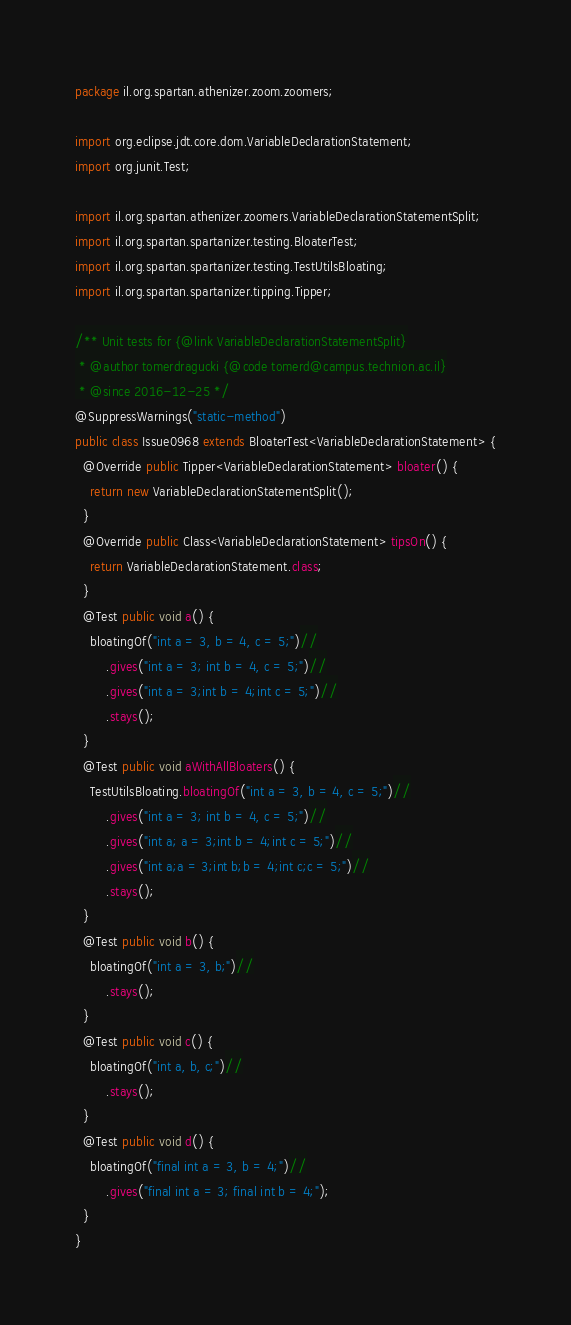Convert code to text. <code><loc_0><loc_0><loc_500><loc_500><_Java_>package il.org.spartan.athenizer.zoom.zoomers;

import org.eclipse.jdt.core.dom.VariableDeclarationStatement;
import org.junit.Test;

import il.org.spartan.athenizer.zoomers.VariableDeclarationStatementSplit;
import il.org.spartan.spartanizer.testing.BloaterTest;
import il.org.spartan.spartanizer.testing.TestUtilsBloating;
import il.org.spartan.spartanizer.tipping.Tipper;

/** Unit tests for {@link VariableDeclarationStatementSplit}
 * @author tomerdragucki {@code tomerd@campus.technion.ac.il}
 * @since 2016-12-25 */
@SuppressWarnings("static-method")
public class Issue0968 extends BloaterTest<VariableDeclarationStatement> {
  @Override public Tipper<VariableDeclarationStatement> bloater() {
    return new VariableDeclarationStatementSplit();
  }
  @Override public Class<VariableDeclarationStatement> tipsOn() {
    return VariableDeclarationStatement.class;
  }
  @Test public void a() {
    bloatingOf("int a = 3, b = 4, c = 5;")//
        .gives("int a = 3; int b = 4, c = 5;")//
        .gives("int a = 3;int b = 4;int c = 5;")//
        .stays();
  }
  @Test public void aWithAllBloaters() {
    TestUtilsBloating.bloatingOf("int a = 3, b = 4, c = 5;")//
        .gives("int a = 3; int b = 4, c = 5;")//
        .gives("int a; a = 3;int b = 4;int c = 5;")//
        .gives("int a;a = 3;int b;b = 4;int c;c = 5;")//
        .stays();
  }
  @Test public void b() {
    bloatingOf("int a = 3, b;")//
        .stays();
  }
  @Test public void c() {
    bloatingOf("int a, b, c;")//
        .stays();
  }
  @Test public void d() {
    bloatingOf("final int a = 3, b = 4;")//
        .gives("final int a = 3; final int b = 4;");
  }
}
</code> 